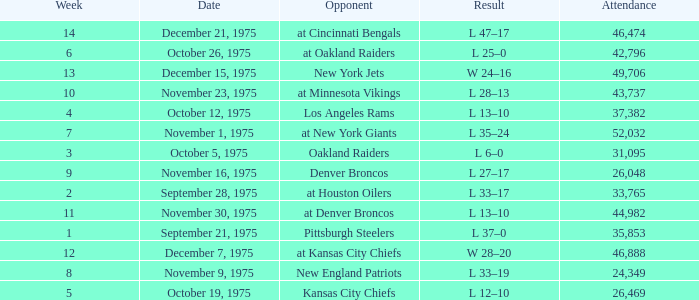What is the highest Week when the opponent was kansas city chiefs, with more than 26,469 in attendance? None. 